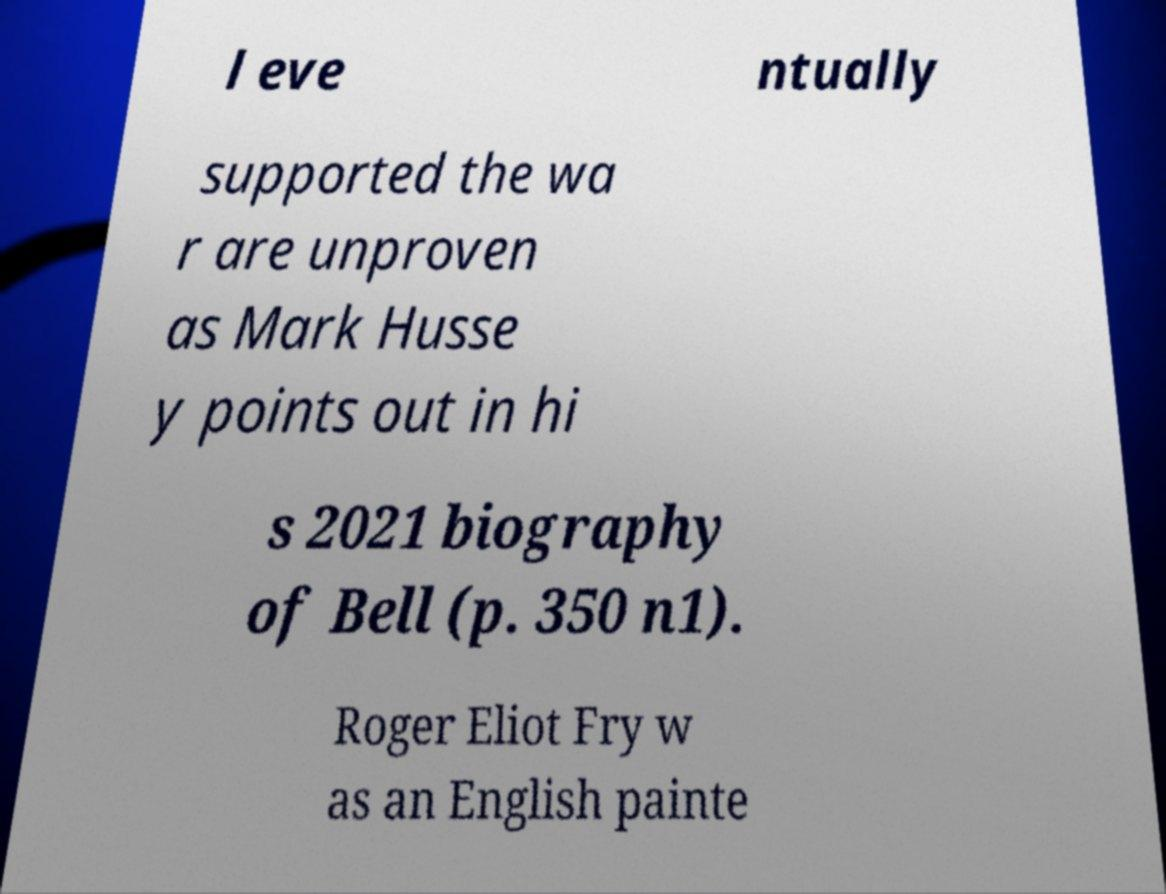I need the written content from this picture converted into text. Can you do that? l eve ntually supported the wa r are unproven as Mark Husse y points out in hi s 2021 biography of Bell (p. 350 n1). Roger Eliot Fry w as an English painte 